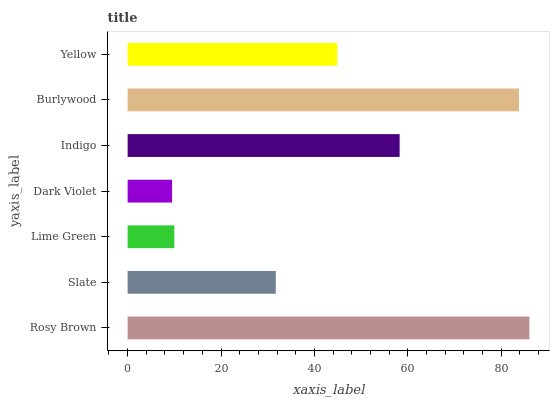Is Dark Violet the minimum?
Answer yes or no. Yes. Is Rosy Brown the maximum?
Answer yes or no. Yes. Is Slate the minimum?
Answer yes or no. No. Is Slate the maximum?
Answer yes or no. No. Is Rosy Brown greater than Slate?
Answer yes or no. Yes. Is Slate less than Rosy Brown?
Answer yes or no. Yes. Is Slate greater than Rosy Brown?
Answer yes or no. No. Is Rosy Brown less than Slate?
Answer yes or no. No. Is Yellow the high median?
Answer yes or no. Yes. Is Yellow the low median?
Answer yes or no. Yes. Is Lime Green the high median?
Answer yes or no. No. Is Burlywood the low median?
Answer yes or no. No. 